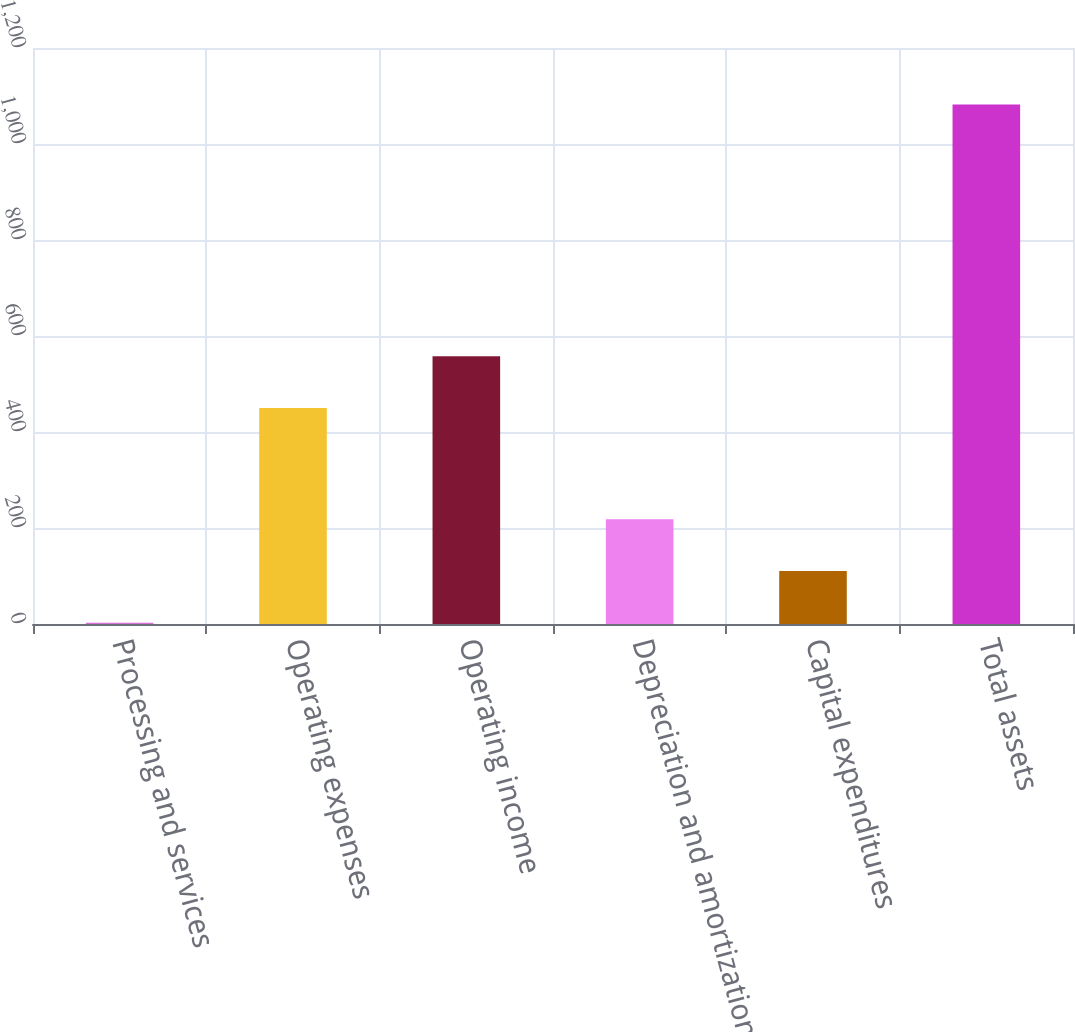<chart> <loc_0><loc_0><loc_500><loc_500><bar_chart><fcel>Processing and services<fcel>Operating expenses<fcel>Operating income<fcel>Depreciation and amortization<fcel>Capital expenditures<fcel>Total assets<nl><fcel>2.5<fcel>449.9<fcel>557.89<fcel>218.48<fcel>110.49<fcel>1082.4<nl></chart> 